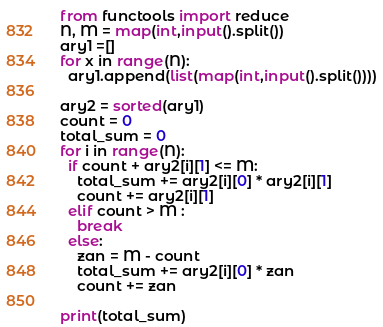<code> <loc_0><loc_0><loc_500><loc_500><_Python_>from functools import reduce
N, M = map(int,input().split())
ary1 =[]
for x in range(N):
  ary1.append(list(map(int,input().split())))

ary2 = sorted(ary1)
count = 0
total_sum = 0
for i in range(N):
  if count + ary2[i][1] <= M:
    total_sum += ary2[i][0] * ary2[i][1]
    count += ary2[i][1]
  elif count > M :
    break
  else:
    zan = M - count
    total_sum += ary2[i][0] * zan
    count += zan

print(total_sum)</code> 